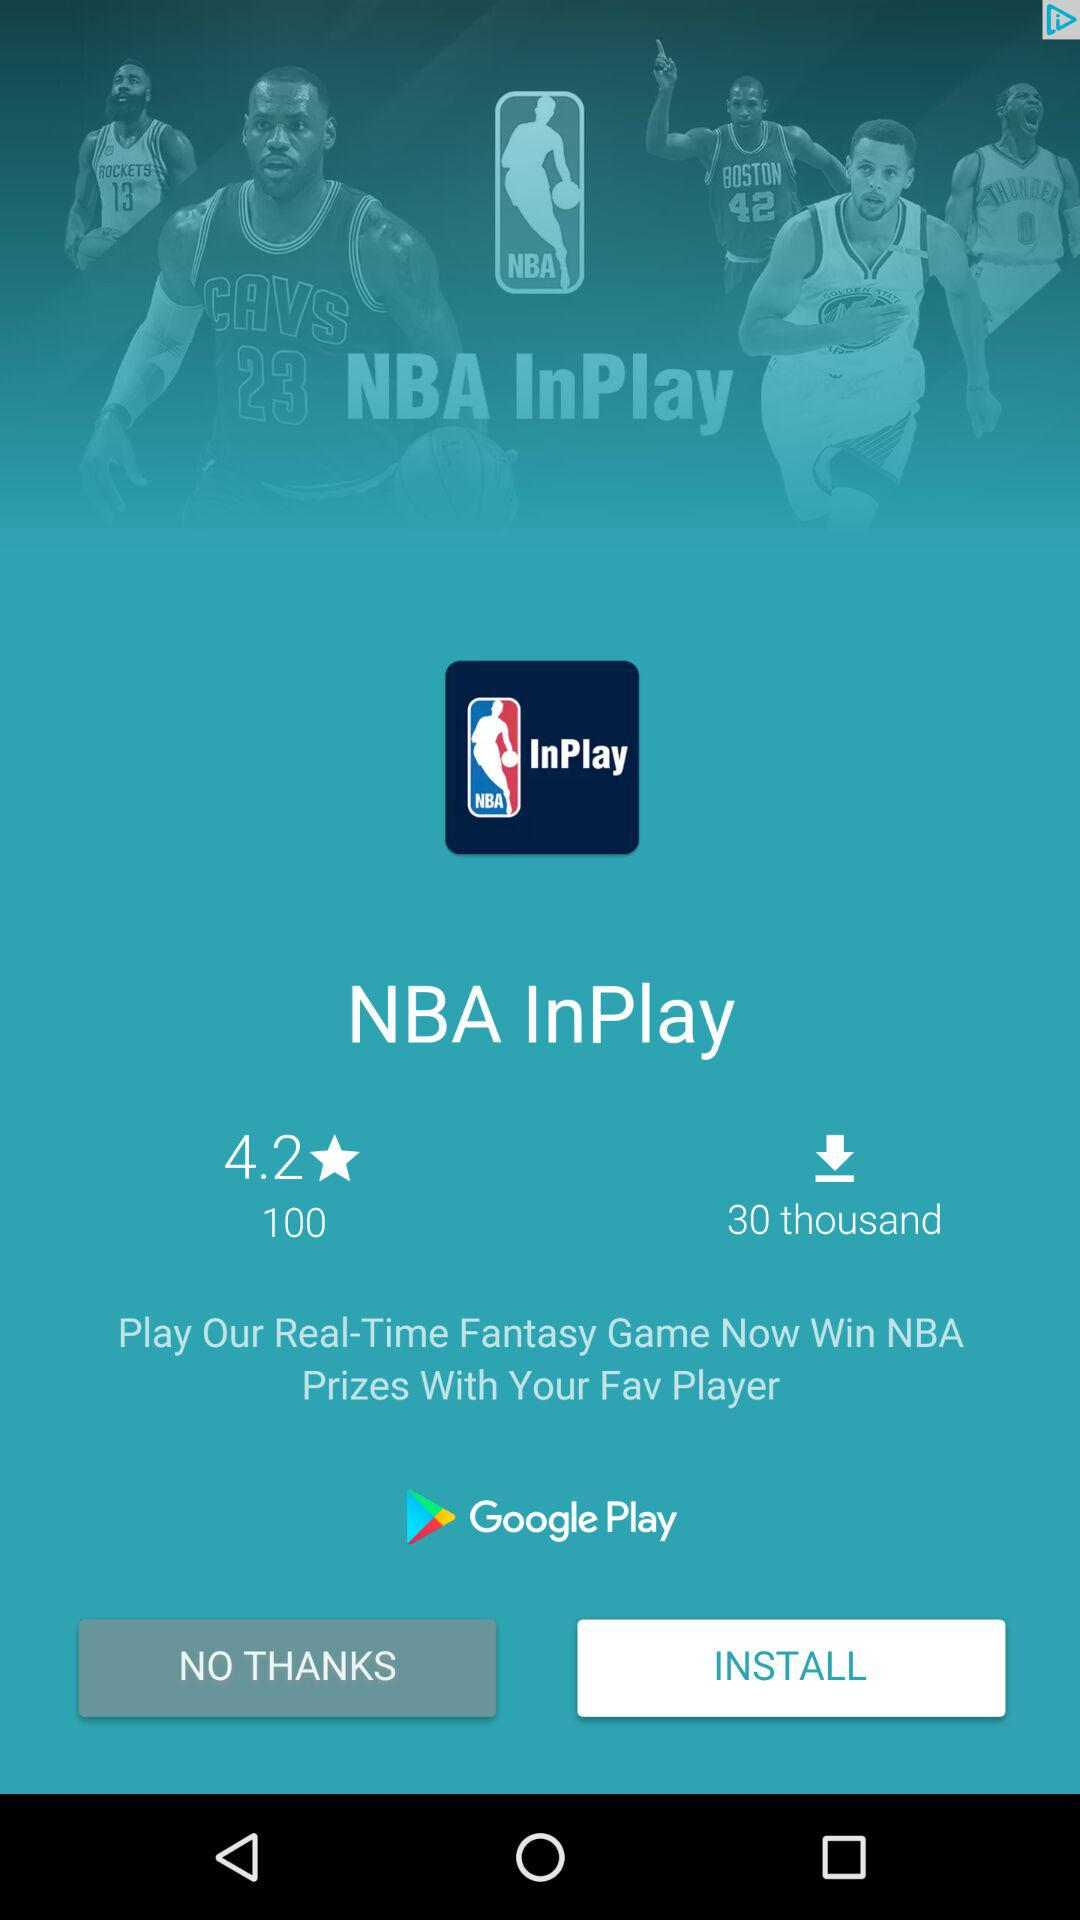How many downloads does the app have?
Answer the question using a single word or phrase. 30 thousand 